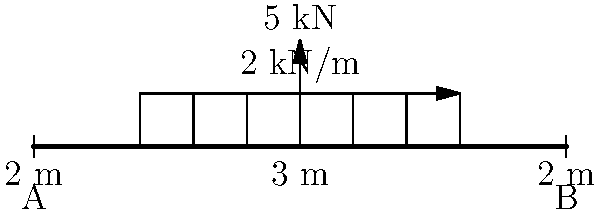In this groovy setup, we've got a righteous beam that's simply supported at both ends, dig? It's carrying a funky distributed load of 2 kN/m over a 6 m length in the middle, and a far-out point load of 5 kN at the center. Now, cool cat, can you lay down the maximum shear force and bending moment this beam's feeling? It's like finding the climax in a Shaft movie! Alright, let's break it down like we're dissecting a classic blaxploitation flick:

1) First, we gotta find the reaction forces at the supports:
   Total distributed load = $2 \text{ kN/m} \times 6 \text{ m} = 12 \text{ kN}$
   Sum of all vertical forces:
   $$R_A + R_B = 12 \text{ kN} + 5 \text{ kN} = 17 \text{ kN}$$
   Taking moment about A:
   $$10R_B = 12 \text{ kN} \times 5 \text{ m} + 5 \text{ kN} \times 5 \text{ m}$$
   $$R_B = 8.5 \text{ kN}, R_A = 8.5 \text{ kN}$$

2) Now, for the shear force diagram:
   - It starts at 8.5 kN at A
   - Decreases linearly to 2.5 kN just before the center
   - Jumps down by 5 kN at the center to -2.5 kN
   - Continues decreasing linearly to -8.5 kN at B

3) The maximum shear force is 8.5 kN (absolute value) at both supports.

4) For the bending moment:
   - It's zero at both supports
   - Increases parabolically to the left of center
   - Reaches its maximum at the center

5) To find the maximum bending moment at the center:
   $$M_{max} = R_A \times 5 \text{ m} - 2 \text{ kN/m} \times 3 \text{ m} \times 1.5 \text{ m}$$
   $$M_{max} = 8.5 \text{ kN} \times 5 \text{ m} - 9 \text{ kN} \times 1.5 \text{ m} = 29.25 \text{ kN}\cdot\text{m}$$

So, there you have it, as smooth as a Superfly soundtrack!
Answer: Maximum shear force: 8.5 kN; Maximum bending moment: 29.25 kN·m 